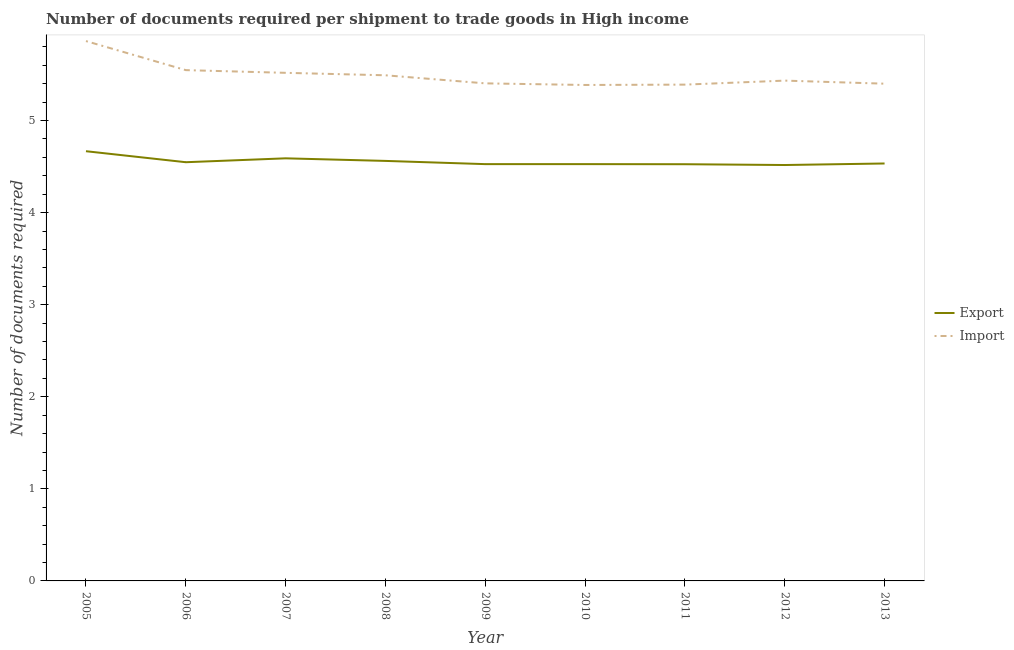Does the line corresponding to number of documents required to import goods intersect with the line corresponding to number of documents required to export goods?
Make the answer very short. No. Is the number of lines equal to the number of legend labels?
Keep it short and to the point. Yes. What is the number of documents required to import goods in 2006?
Your answer should be very brief. 5.55. Across all years, what is the maximum number of documents required to export goods?
Offer a very short reply. 4.67. Across all years, what is the minimum number of documents required to import goods?
Your answer should be compact. 5.39. In which year was the number of documents required to import goods maximum?
Ensure brevity in your answer.  2005. In which year was the number of documents required to import goods minimum?
Keep it short and to the point. 2010. What is the total number of documents required to export goods in the graph?
Your answer should be compact. 40.99. What is the difference between the number of documents required to export goods in 2005 and that in 2008?
Offer a very short reply. 0.11. What is the difference between the number of documents required to export goods in 2010 and the number of documents required to import goods in 2005?
Offer a very short reply. -1.34. What is the average number of documents required to import goods per year?
Ensure brevity in your answer.  5.49. In the year 2012, what is the difference between the number of documents required to import goods and number of documents required to export goods?
Offer a terse response. 0.92. What is the ratio of the number of documents required to export goods in 2006 to that in 2007?
Your answer should be very brief. 0.99. Is the number of documents required to import goods in 2008 less than that in 2013?
Provide a succinct answer. No. What is the difference between the highest and the second highest number of documents required to export goods?
Keep it short and to the point. 0.08. What is the difference between the highest and the lowest number of documents required to import goods?
Your answer should be very brief. 0.48. In how many years, is the number of documents required to export goods greater than the average number of documents required to export goods taken over all years?
Your answer should be very brief. 3. Is the sum of the number of documents required to export goods in 2007 and 2010 greater than the maximum number of documents required to import goods across all years?
Offer a terse response. Yes. Does the number of documents required to import goods monotonically increase over the years?
Offer a very short reply. No. Is the number of documents required to export goods strictly less than the number of documents required to import goods over the years?
Provide a succinct answer. Yes. What is the difference between two consecutive major ticks on the Y-axis?
Offer a terse response. 1. Does the graph contain any zero values?
Your response must be concise. No. Does the graph contain grids?
Your answer should be compact. No. How many legend labels are there?
Offer a terse response. 2. How are the legend labels stacked?
Ensure brevity in your answer.  Vertical. What is the title of the graph?
Make the answer very short. Number of documents required per shipment to trade goods in High income. Does "Nonresident" appear as one of the legend labels in the graph?
Ensure brevity in your answer.  No. What is the label or title of the X-axis?
Ensure brevity in your answer.  Year. What is the label or title of the Y-axis?
Provide a succinct answer. Number of documents required. What is the Number of documents required in Export in 2005?
Offer a very short reply. 4.67. What is the Number of documents required in Import in 2005?
Your answer should be compact. 5.86. What is the Number of documents required of Export in 2006?
Make the answer very short. 4.55. What is the Number of documents required of Import in 2006?
Ensure brevity in your answer.  5.55. What is the Number of documents required in Export in 2007?
Your answer should be compact. 4.59. What is the Number of documents required in Import in 2007?
Offer a very short reply. 5.52. What is the Number of documents required of Export in 2008?
Provide a succinct answer. 4.56. What is the Number of documents required in Import in 2008?
Your answer should be very brief. 5.49. What is the Number of documents required of Export in 2009?
Make the answer very short. 4.53. What is the Number of documents required in Import in 2009?
Provide a short and direct response. 5.4. What is the Number of documents required of Export in 2010?
Your answer should be compact. 4.53. What is the Number of documents required of Import in 2010?
Your answer should be very brief. 5.39. What is the Number of documents required of Export in 2011?
Your answer should be very brief. 4.53. What is the Number of documents required of Import in 2011?
Provide a short and direct response. 5.39. What is the Number of documents required in Export in 2012?
Provide a succinct answer. 4.52. What is the Number of documents required in Import in 2012?
Make the answer very short. 5.43. What is the Number of documents required in Export in 2013?
Ensure brevity in your answer.  4.53. What is the Number of documents required in Import in 2013?
Make the answer very short. 5.4. Across all years, what is the maximum Number of documents required of Export?
Keep it short and to the point. 4.67. Across all years, what is the maximum Number of documents required in Import?
Offer a very short reply. 5.86. Across all years, what is the minimum Number of documents required in Export?
Your answer should be very brief. 4.52. Across all years, what is the minimum Number of documents required in Import?
Keep it short and to the point. 5.39. What is the total Number of documents required of Export in the graph?
Provide a short and direct response. 40.99. What is the total Number of documents required in Import in the graph?
Make the answer very short. 49.43. What is the difference between the Number of documents required in Export in 2005 and that in 2006?
Your answer should be compact. 0.12. What is the difference between the Number of documents required in Import in 2005 and that in 2006?
Offer a terse response. 0.32. What is the difference between the Number of documents required of Export in 2005 and that in 2007?
Keep it short and to the point. 0.08. What is the difference between the Number of documents required of Import in 2005 and that in 2007?
Your answer should be compact. 0.34. What is the difference between the Number of documents required of Export in 2005 and that in 2008?
Keep it short and to the point. 0.11. What is the difference between the Number of documents required in Import in 2005 and that in 2008?
Ensure brevity in your answer.  0.37. What is the difference between the Number of documents required of Export in 2005 and that in 2009?
Your response must be concise. 0.14. What is the difference between the Number of documents required in Import in 2005 and that in 2009?
Provide a short and direct response. 0.46. What is the difference between the Number of documents required of Export in 2005 and that in 2010?
Provide a succinct answer. 0.14. What is the difference between the Number of documents required of Import in 2005 and that in 2010?
Make the answer very short. 0.48. What is the difference between the Number of documents required in Export in 2005 and that in 2011?
Give a very brief answer. 0.14. What is the difference between the Number of documents required of Import in 2005 and that in 2011?
Ensure brevity in your answer.  0.47. What is the difference between the Number of documents required of Import in 2005 and that in 2012?
Give a very brief answer. 0.43. What is the difference between the Number of documents required in Export in 2005 and that in 2013?
Give a very brief answer. 0.13. What is the difference between the Number of documents required in Import in 2005 and that in 2013?
Provide a short and direct response. 0.46. What is the difference between the Number of documents required of Export in 2006 and that in 2007?
Ensure brevity in your answer.  -0.04. What is the difference between the Number of documents required in Import in 2006 and that in 2007?
Make the answer very short. 0.03. What is the difference between the Number of documents required in Export in 2006 and that in 2008?
Ensure brevity in your answer.  -0.01. What is the difference between the Number of documents required in Import in 2006 and that in 2008?
Offer a terse response. 0.06. What is the difference between the Number of documents required in Export in 2006 and that in 2009?
Give a very brief answer. 0.02. What is the difference between the Number of documents required of Import in 2006 and that in 2009?
Your answer should be very brief. 0.14. What is the difference between the Number of documents required in Export in 2006 and that in 2010?
Ensure brevity in your answer.  0.02. What is the difference between the Number of documents required in Import in 2006 and that in 2010?
Provide a short and direct response. 0.16. What is the difference between the Number of documents required of Export in 2006 and that in 2011?
Provide a succinct answer. 0.02. What is the difference between the Number of documents required in Import in 2006 and that in 2011?
Your answer should be very brief. 0.16. What is the difference between the Number of documents required in Export in 2006 and that in 2012?
Ensure brevity in your answer.  0.03. What is the difference between the Number of documents required in Import in 2006 and that in 2012?
Your response must be concise. 0.11. What is the difference between the Number of documents required in Export in 2006 and that in 2013?
Your answer should be very brief. 0.01. What is the difference between the Number of documents required in Import in 2006 and that in 2013?
Keep it short and to the point. 0.15. What is the difference between the Number of documents required of Export in 2007 and that in 2008?
Your answer should be compact. 0.03. What is the difference between the Number of documents required of Import in 2007 and that in 2008?
Your answer should be compact. 0.03. What is the difference between the Number of documents required of Export in 2007 and that in 2009?
Provide a short and direct response. 0.06. What is the difference between the Number of documents required of Import in 2007 and that in 2009?
Your answer should be very brief. 0.11. What is the difference between the Number of documents required in Export in 2007 and that in 2010?
Offer a very short reply. 0.06. What is the difference between the Number of documents required in Import in 2007 and that in 2010?
Offer a terse response. 0.13. What is the difference between the Number of documents required in Export in 2007 and that in 2011?
Your response must be concise. 0.06. What is the difference between the Number of documents required of Import in 2007 and that in 2011?
Your answer should be compact. 0.13. What is the difference between the Number of documents required in Export in 2007 and that in 2012?
Offer a very short reply. 0.07. What is the difference between the Number of documents required of Import in 2007 and that in 2012?
Give a very brief answer. 0.08. What is the difference between the Number of documents required of Export in 2007 and that in 2013?
Make the answer very short. 0.06. What is the difference between the Number of documents required of Import in 2007 and that in 2013?
Your answer should be very brief. 0.12. What is the difference between the Number of documents required of Export in 2008 and that in 2009?
Your answer should be very brief. 0.04. What is the difference between the Number of documents required in Import in 2008 and that in 2009?
Keep it short and to the point. 0.09. What is the difference between the Number of documents required of Export in 2008 and that in 2010?
Provide a succinct answer. 0.04. What is the difference between the Number of documents required in Import in 2008 and that in 2010?
Offer a very short reply. 0.11. What is the difference between the Number of documents required in Export in 2008 and that in 2011?
Ensure brevity in your answer.  0.04. What is the difference between the Number of documents required in Import in 2008 and that in 2011?
Offer a terse response. 0.1. What is the difference between the Number of documents required of Export in 2008 and that in 2012?
Keep it short and to the point. 0.04. What is the difference between the Number of documents required in Import in 2008 and that in 2012?
Ensure brevity in your answer.  0.06. What is the difference between the Number of documents required in Export in 2008 and that in 2013?
Provide a succinct answer. 0.03. What is the difference between the Number of documents required in Import in 2008 and that in 2013?
Your response must be concise. 0.09. What is the difference between the Number of documents required of Import in 2009 and that in 2010?
Keep it short and to the point. 0.02. What is the difference between the Number of documents required of Export in 2009 and that in 2011?
Ensure brevity in your answer.  0. What is the difference between the Number of documents required of Import in 2009 and that in 2011?
Your answer should be very brief. 0.01. What is the difference between the Number of documents required in Export in 2009 and that in 2012?
Keep it short and to the point. 0.01. What is the difference between the Number of documents required in Import in 2009 and that in 2012?
Offer a very short reply. -0.03. What is the difference between the Number of documents required of Export in 2009 and that in 2013?
Keep it short and to the point. -0.01. What is the difference between the Number of documents required in Import in 2009 and that in 2013?
Keep it short and to the point. 0. What is the difference between the Number of documents required of Export in 2010 and that in 2011?
Your answer should be compact. 0. What is the difference between the Number of documents required in Import in 2010 and that in 2011?
Keep it short and to the point. -0. What is the difference between the Number of documents required of Export in 2010 and that in 2012?
Provide a short and direct response. 0.01. What is the difference between the Number of documents required in Import in 2010 and that in 2012?
Your answer should be compact. -0.05. What is the difference between the Number of documents required of Export in 2010 and that in 2013?
Keep it short and to the point. -0.01. What is the difference between the Number of documents required in Import in 2010 and that in 2013?
Offer a very short reply. -0.01. What is the difference between the Number of documents required in Export in 2011 and that in 2012?
Your response must be concise. 0.01. What is the difference between the Number of documents required of Import in 2011 and that in 2012?
Your answer should be compact. -0.04. What is the difference between the Number of documents required in Export in 2011 and that in 2013?
Keep it short and to the point. -0.01. What is the difference between the Number of documents required in Import in 2011 and that in 2013?
Your answer should be compact. -0.01. What is the difference between the Number of documents required of Export in 2012 and that in 2013?
Offer a terse response. -0.02. What is the difference between the Number of documents required in Import in 2012 and that in 2013?
Offer a very short reply. 0.03. What is the difference between the Number of documents required in Export in 2005 and the Number of documents required in Import in 2006?
Offer a very short reply. -0.88. What is the difference between the Number of documents required in Export in 2005 and the Number of documents required in Import in 2007?
Provide a short and direct response. -0.85. What is the difference between the Number of documents required in Export in 2005 and the Number of documents required in Import in 2008?
Provide a succinct answer. -0.82. What is the difference between the Number of documents required of Export in 2005 and the Number of documents required of Import in 2009?
Provide a succinct answer. -0.74. What is the difference between the Number of documents required in Export in 2005 and the Number of documents required in Import in 2010?
Provide a short and direct response. -0.72. What is the difference between the Number of documents required in Export in 2005 and the Number of documents required in Import in 2011?
Provide a succinct answer. -0.72. What is the difference between the Number of documents required of Export in 2005 and the Number of documents required of Import in 2012?
Your answer should be very brief. -0.77. What is the difference between the Number of documents required in Export in 2005 and the Number of documents required in Import in 2013?
Give a very brief answer. -0.73. What is the difference between the Number of documents required in Export in 2006 and the Number of documents required in Import in 2007?
Keep it short and to the point. -0.97. What is the difference between the Number of documents required in Export in 2006 and the Number of documents required in Import in 2008?
Your response must be concise. -0.94. What is the difference between the Number of documents required of Export in 2006 and the Number of documents required of Import in 2009?
Provide a short and direct response. -0.86. What is the difference between the Number of documents required of Export in 2006 and the Number of documents required of Import in 2010?
Your answer should be compact. -0.84. What is the difference between the Number of documents required in Export in 2006 and the Number of documents required in Import in 2011?
Ensure brevity in your answer.  -0.84. What is the difference between the Number of documents required in Export in 2006 and the Number of documents required in Import in 2012?
Make the answer very short. -0.89. What is the difference between the Number of documents required of Export in 2006 and the Number of documents required of Import in 2013?
Offer a terse response. -0.85. What is the difference between the Number of documents required of Export in 2007 and the Number of documents required of Import in 2008?
Your answer should be very brief. -0.9. What is the difference between the Number of documents required in Export in 2007 and the Number of documents required in Import in 2009?
Offer a terse response. -0.81. What is the difference between the Number of documents required in Export in 2007 and the Number of documents required in Import in 2010?
Give a very brief answer. -0.8. What is the difference between the Number of documents required of Export in 2007 and the Number of documents required of Import in 2011?
Your answer should be very brief. -0.8. What is the difference between the Number of documents required of Export in 2007 and the Number of documents required of Import in 2012?
Your answer should be compact. -0.84. What is the difference between the Number of documents required in Export in 2007 and the Number of documents required in Import in 2013?
Give a very brief answer. -0.81. What is the difference between the Number of documents required of Export in 2008 and the Number of documents required of Import in 2009?
Your answer should be very brief. -0.84. What is the difference between the Number of documents required of Export in 2008 and the Number of documents required of Import in 2010?
Your response must be concise. -0.82. What is the difference between the Number of documents required of Export in 2008 and the Number of documents required of Import in 2011?
Your response must be concise. -0.83. What is the difference between the Number of documents required of Export in 2008 and the Number of documents required of Import in 2012?
Offer a terse response. -0.87. What is the difference between the Number of documents required of Export in 2008 and the Number of documents required of Import in 2013?
Offer a very short reply. -0.84. What is the difference between the Number of documents required in Export in 2009 and the Number of documents required in Import in 2010?
Provide a succinct answer. -0.86. What is the difference between the Number of documents required in Export in 2009 and the Number of documents required in Import in 2011?
Provide a short and direct response. -0.86. What is the difference between the Number of documents required of Export in 2009 and the Number of documents required of Import in 2012?
Offer a very short reply. -0.91. What is the difference between the Number of documents required in Export in 2009 and the Number of documents required in Import in 2013?
Your answer should be compact. -0.87. What is the difference between the Number of documents required of Export in 2010 and the Number of documents required of Import in 2011?
Offer a very short reply. -0.86. What is the difference between the Number of documents required in Export in 2010 and the Number of documents required in Import in 2012?
Your answer should be compact. -0.91. What is the difference between the Number of documents required of Export in 2010 and the Number of documents required of Import in 2013?
Provide a succinct answer. -0.87. What is the difference between the Number of documents required in Export in 2011 and the Number of documents required in Import in 2012?
Your response must be concise. -0.91. What is the difference between the Number of documents required of Export in 2011 and the Number of documents required of Import in 2013?
Offer a terse response. -0.87. What is the difference between the Number of documents required of Export in 2012 and the Number of documents required of Import in 2013?
Your response must be concise. -0.88. What is the average Number of documents required in Export per year?
Make the answer very short. 4.55. What is the average Number of documents required of Import per year?
Give a very brief answer. 5.49. In the year 2005, what is the difference between the Number of documents required of Export and Number of documents required of Import?
Provide a succinct answer. -1.2. In the year 2007, what is the difference between the Number of documents required in Export and Number of documents required in Import?
Give a very brief answer. -0.93. In the year 2008, what is the difference between the Number of documents required in Export and Number of documents required in Import?
Offer a very short reply. -0.93. In the year 2009, what is the difference between the Number of documents required of Export and Number of documents required of Import?
Give a very brief answer. -0.88. In the year 2010, what is the difference between the Number of documents required of Export and Number of documents required of Import?
Offer a terse response. -0.86. In the year 2011, what is the difference between the Number of documents required of Export and Number of documents required of Import?
Your response must be concise. -0.86. In the year 2012, what is the difference between the Number of documents required of Export and Number of documents required of Import?
Make the answer very short. -0.92. In the year 2013, what is the difference between the Number of documents required in Export and Number of documents required in Import?
Offer a very short reply. -0.87. What is the ratio of the Number of documents required of Export in 2005 to that in 2006?
Your answer should be very brief. 1.03. What is the ratio of the Number of documents required in Import in 2005 to that in 2006?
Give a very brief answer. 1.06. What is the ratio of the Number of documents required of Export in 2005 to that in 2007?
Offer a very short reply. 1.02. What is the ratio of the Number of documents required in Import in 2005 to that in 2007?
Give a very brief answer. 1.06. What is the ratio of the Number of documents required in Export in 2005 to that in 2008?
Offer a terse response. 1.02. What is the ratio of the Number of documents required in Import in 2005 to that in 2008?
Make the answer very short. 1.07. What is the ratio of the Number of documents required in Export in 2005 to that in 2009?
Offer a very short reply. 1.03. What is the ratio of the Number of documents required of Import in 2005 to that in 2009?
Keep it short and to the point. 1.08. What is the ratio of the Number of documents required in Export in 2005 to that in 2010?
Provide a succinct answer. 1.03. What is the ratio of the Number of documents required of Import in 2005 to that in 2010?
Make the answer very short. 1.09. What is the ratio of the Number of documents required of Export in 2005 to that in 2011?
Keep it short and to the point. 1.03. What is the ratio of the Number of documents required of Import in 2005 to that in 2011?
Your response must be concise. 1.09. What is the ratio of the Number of documents required in Export in 2005 to that in 2012?
Give a very brief answer. 1.03. What is the ratio of the Number of documents required of Import in 2005 to that in 2012?
Offer a terse response. 1.08. What is the ratio of the Number of documents required in Export in 2005 to that in 2013?
Your answer should be very brief. 1.03. What is the ratio of the Number of documents required in Import in 2005 to that in 2013?
Offer a very short reply. 1.09. What is the ratio of the Number of documents required in Export in 2006 to that in 2007?
Offer a very short reply. 0.99. What is the ratio of the Number of documents required in Import in 2006 to that in 2008?
Keep it short and to the point. 1.01. What is the ratio of the Number of documents required of Export in 2006 to that in 2009?
Offer a terse response. 1. What is the ratio of the Number of documents required of Import in 2006 to that in 2009?
Your response must be concise. 1.03. What is the ratio of the Number of documents required in Export in 2006 to that in 2010?
Make the answer very short. 1. What is the ratio of the Number of documents required in Import in 2006 to that in 2010?
Your answer should be compact. 1.03. What is the ratio of the Number of documents required in Import in 2006 to that in 2011?
Ensure brevity in your answer.  1.03. What is the ratio of the Number of documents required of Export in 2006 to that in 2012?
Provide a short and direct response. 1.01. What is the ratio of the Number of documents required of Export in 2006 to that in 2013?
Your answer should be compact. 1. What is the ratio of the Number of documents required of Import in 2006 to that in 2013?
Offer a very short reply. 1.03. What is the ratio of the Number of documents required in Export in 2007 to that in 2009?
Ensure brevity in your answer.  1.01. What is the ratio of the Number of documents required in Import in 2007 to that in 2009?
Ensure brevity in your answer.  1.02. What is the ratio of the Number of documents required of Export in 2007 to that in 2010?
Provide a succinct answer. 1.01. What is the ratio of the Number of documents required of Import in 2007 to that in 2010?
Offer a very short reply. 1.02. What is the ratio of the Number of documents required in Export in 2007 to that in 2011?
Your answer should be compact. 1.01. What is the ratio of the Number of documents required in Import in 2007 to that in 2011?
Keep it short and to the point. 1.02. What is the ratio of the Number of documents required of Export in 2007 to that in 2012?
Ensure brevity in your answer.  1.02. What is the ratio of the Number of documents required of Import in 2007 to that in 2012?
Give a very brief answer. 1.02. What is the ratio of the Number of documents required in Export in 2007 to that in 2013?
Offer a very short reply. 1.01. What is the ratio of the Number of documents required of Import in 2007 to that in 2013?
Make the answer very short. 1.02. What is the ratio of the Number of documents required of Export in 2008 to that in 2009?
Keep it short and to the point. 1.01. What is the ratio of the Number of documents required in Import in 2008 to that in 2009?
Your answer should be compact. 1.02. What is the ratio of the Number of documents required of Export in 2008 to that in 2010?
Provide a short and direct response. 1.01. What is the ratio of the Number of documents required in Import in 2008 to that in 2010?
Your answer should be compact. 1.02. What is the ratio of the Number of documents required of Export in 2008 to that in 2011?
Offer a very short reply. 1.01. What is the ratio of the Number of documents required in Import in 2008 to that in 2011?
Your answer should be compact. 1.02. What is the ratio of the Number of documents required of Export in 2008 to that in 2012?
Your answer should be compact. 1.01. What is the ratio of the Number of documents required of Import in 2008 to that in 2012?
Give a very brief answer. 1.01. What is the ratio of the Number of documents required of Import in 2008 to that in 2013?
Offer a very short reply. 1.02. What is the ratio of the Number of documents required of Export in 2009 to that in 2010?
Your answer should be compact. 1. What is the ratio of the Number of documents required of Import in 2009 to that in 2010?
Offer a terse response. 1. What is the ratio of the Number of documents required in Export in 2009 to that in 2011?
Make the answer very short. 1. What is the ratio of the Number of documents required of Import in 2009 to that in 2011?
Keep it short and to the point. 1. What is the ratio of the Number of documents required of Export in 2009 to that in 2012?
Your answer should be very brief. 1. What is the ratio of the Number of documents required of Export in 2009 to that in 2013?
Your answer should be compact. 1. What is the ratio of the Number of documents required in Export in 2010 to that in 2011?
Your answer should be very brief. 1. What is the ratio of the Number of documents required of Export in 2010 to that in 2013?
Your answer should be compact. 1. What is the ratio of the Number of documents required of Export in 2011 to that in 2012?
Provide a succinct answer. 1. What is the ratio of the Number of documents required in Import in 2011 to that in 2013?
Give a very brief answer. 1. What is the ratio of the Number of documents required of Import in 2012 to that in 2013?
Give a very brief answer. 1.01. What is the difference between the highest and the second highest Number of documents required of Export?
Offer a very short reply. 0.08. What is the difference between the highest and the second highest Number of documents required of Import?
Make the answer very short. 0.32. What is the difference between the highest and the lowest Number of documents required of Import?
Give a very brief answer. 0.48. 